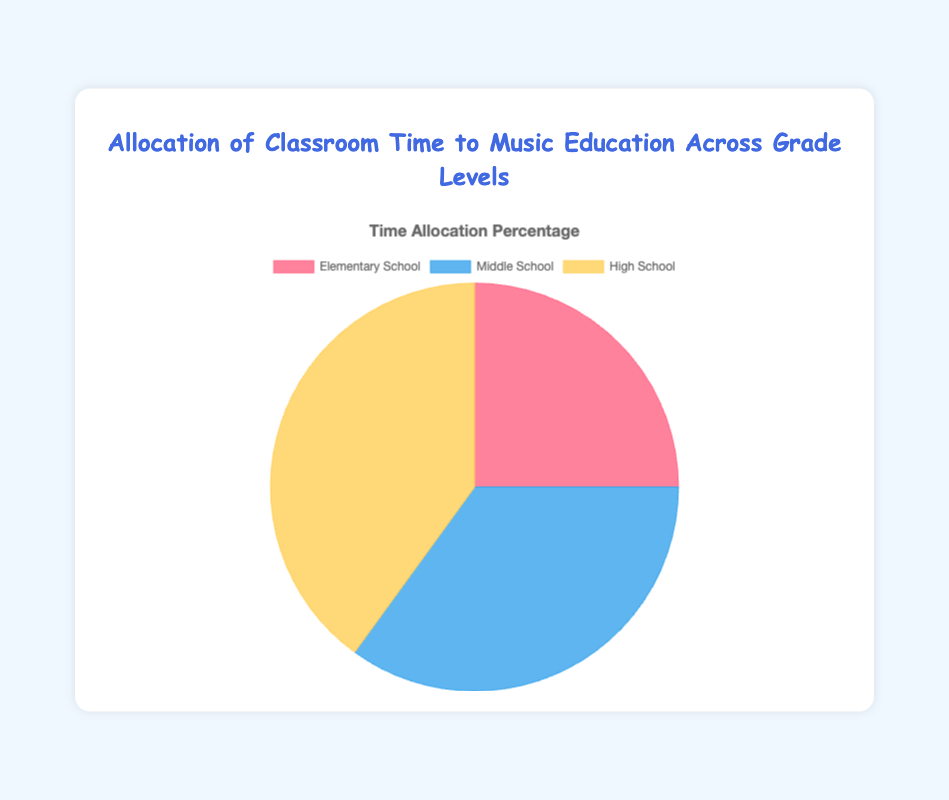what's the percentage of time allocated to music education in Middle School? The pie chart shows that the percentage of time allocated to music education in Middle School is represented by the blue slice, which reads as 35%.
Answer: 35% Compare the time allocation between Elementary School and High School. Which grade level has a higher allocation? The pie chart shows that Elementary School has 25% allocated to music education, while High School has 40%. Therefore, High School has a higher allocation.
Answer: High School What is the combined time allocation percentage of Elementary School and Middle School? The time allocation for Elementary School is 25%, and for Middle School, it is 35%. Adding these together: 25% + 35% = 60%.
Answer: 60% By how much does the time allocation in High School exceed that in Elementary School? High School has 40% time allocated to music education, and Elementary School has 25%. Subtract the Elementary School allocation from the High School allocation: 40% - 25% = 15%.
Answer: 15% Which grade level has the smallest allocation of classroom time to music education? The pie chart indicates that the red slice, representing Elementary School, has the smallest allocation at 25%.
Answer: Elementary School What fraction of the total time allocation is dedicated to Middle School and High School together? Middle School has 35%, and High School has 40%. Together, they make up 35% + 40% = 75% of the total time allocation.
Answer: 75% How does the time allocation for High School compare to the combined allocation for Elementary School and Middle School? The combined allocation for Elementary School and Middle School is 25% + 35% = 60%. High School alone has 40%. The combined allocation (60%) is greater than the High School allocation (40%).
Answer: The combined allocation is greater What percentage of the total time allocation is not assigned to Elementary School? The total percentage is 100%, and Elementary School has 25%. To find the unallocated percentage: 100% - 25% = 75%.
Answer: 75% If the total time allocated to music education is 300 minutes per week, how many minutes are allocated to High School? High School is allocated 40% of the total time. To find the number of minutes: 300 minutes * 0.40 = 120 minutes.
Answer: 120 minutes 